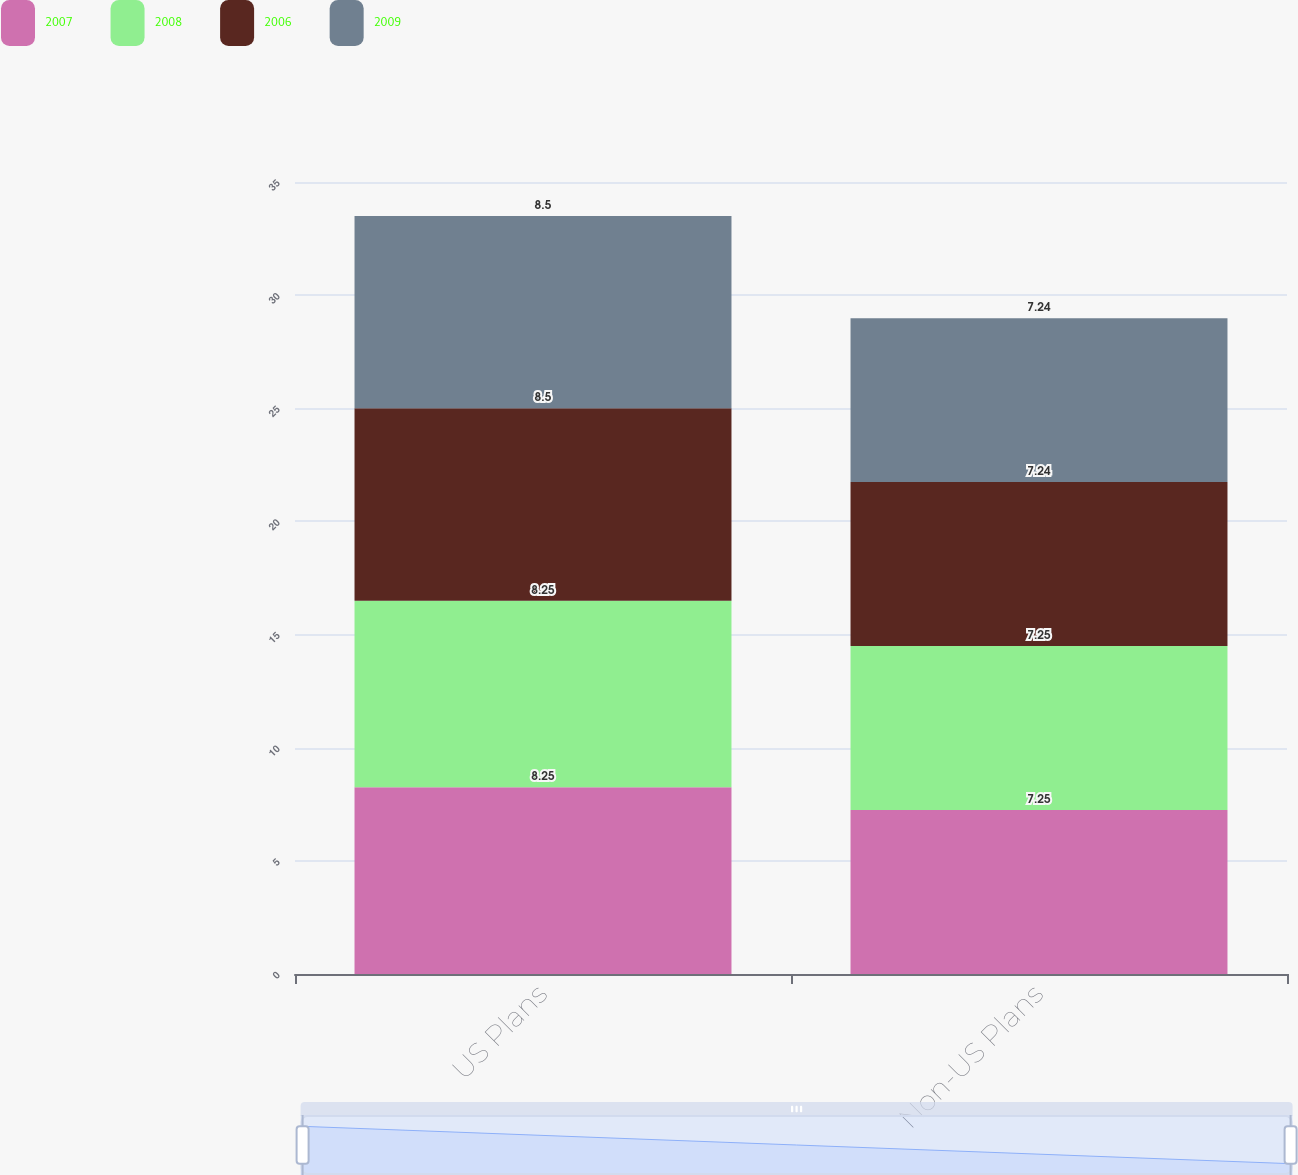<chart> <loc_0><loc_0><loc_500><loc_500><stacked_bar_chart><ecel><fcel>US Plans<fcel>Non-US Plans<nl><fcel>2007<fcel>8.25<fcel>7.25<nl><fcel>2008<fcel>8.25<fcel>7.25<nl><fcel>2006<fcel>8.5<fcel>7.24<nl><fcel>2009<fcel>8.5<fcel>7.24<nl></chart> 